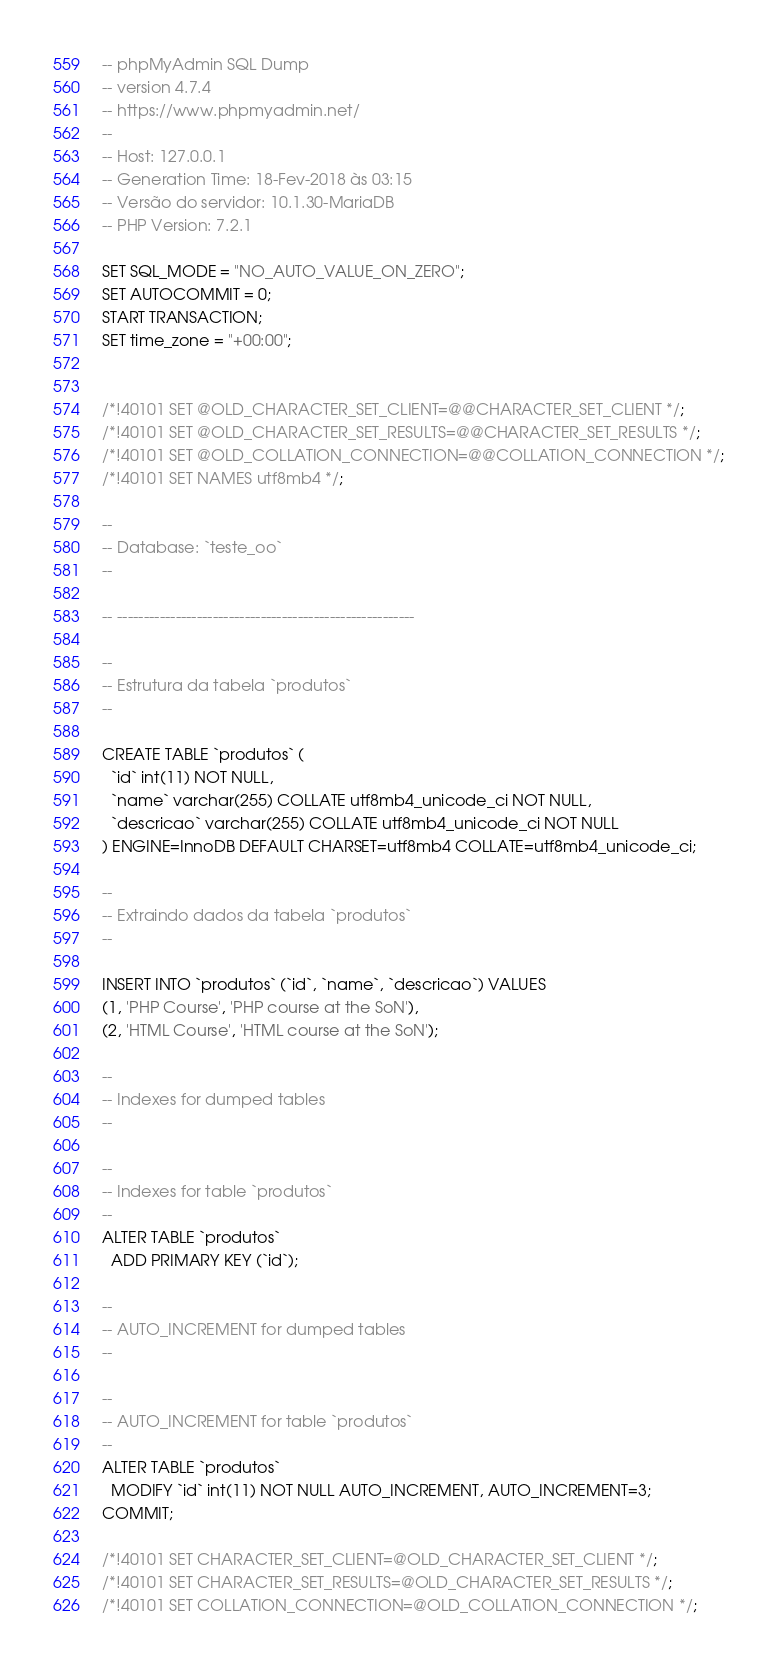<code> <loc_0><loc_0><loc_500><loc_500><_SQL_>-- phpMyAdmin SQL Dump
-- version 4.7.4
-- https://www.phpmyadmin.net/
--
-- Host: 127.0.0.1
-- Generation Time: 18-Fev-2018 às 03:15
-- Versão do servidor: 10.1.30-MariaDB
-- PHP Version: 7.2.1

SET SQL_MODE = "NO_AUTO_VALUE_ON_ZERO";
SET AUTOCOMMIT = 0;
START TRANSACTION;
SET time_zone = "+00:00";


/*!40101 SET @OLD_CHARACTER_SET_CLIENT=@@CHARACTER_SET_CLIENT */;
/*!40101 SET @OLD_CHARACTER_SET_RESULTS=@@CHARACTER_SET_RESULTS */;
/*!40101 SET @OLD_COLLATION_CONNECTION=@@COLLATION_CONNECTION */;
/*!40101 SET NAMES utf8mb4 */;

--
-- Database: `teste_oo`
--

-- --------------------------------------------------------

--
-- Estrutura da tabela `produtos`
--

CREATE TABLE `produtos` (
  `id` int(11) NOT NULL,
  `name` varchar(255) COLLATE utf8mb4_unicode_ci NOT NULL,
  `descricao` varchar(255) COLLATE utf8mb4_unicode_ci NOT NULL
) ENGINE=InnoDB DEFAULT CHARSET=utf8mb4 COLLATE=utf8mb4_unicode_ci;

--
-- Extraindo dados da tabela `produtos`
--

INSERT INTO `produtos` (`id`, `name`, `descricao`) VALUES
(1, 'PHP Course', 'PHP course at the SoN'),
(2, 'HTML Course', 'HTML course at the SoN');

--
-- Indexes for dumped tables
--

--
-- Indexes for table `produtos`
--
ALTER TABLE `produtos`
  ADD PRIMARY KEY (`id`);

--
-- AUTO_INCREMENT for dumped tables
--

--
-- AUTO_INCREMENT for table `produtos`
--
ALTER TABLE `produtos`
  MODIFY `id` int(11) NOT NULL AUTO_INCREMENT, AUTO_INCREMENT=3;
COMMIT;

/*!40101 SET CHARACTER_SET_CLIENT=@OLD_CHARACTER_SET_CLIENT */;
/*!40101 SET CHARACTER_SET_RESULTS=@OLD_CHARACTER_SET_RESULTS */;
/*!40101 SET COLLATION_CONNECTION=@OLD_COLLATION_CONNECTION */;
</code> 